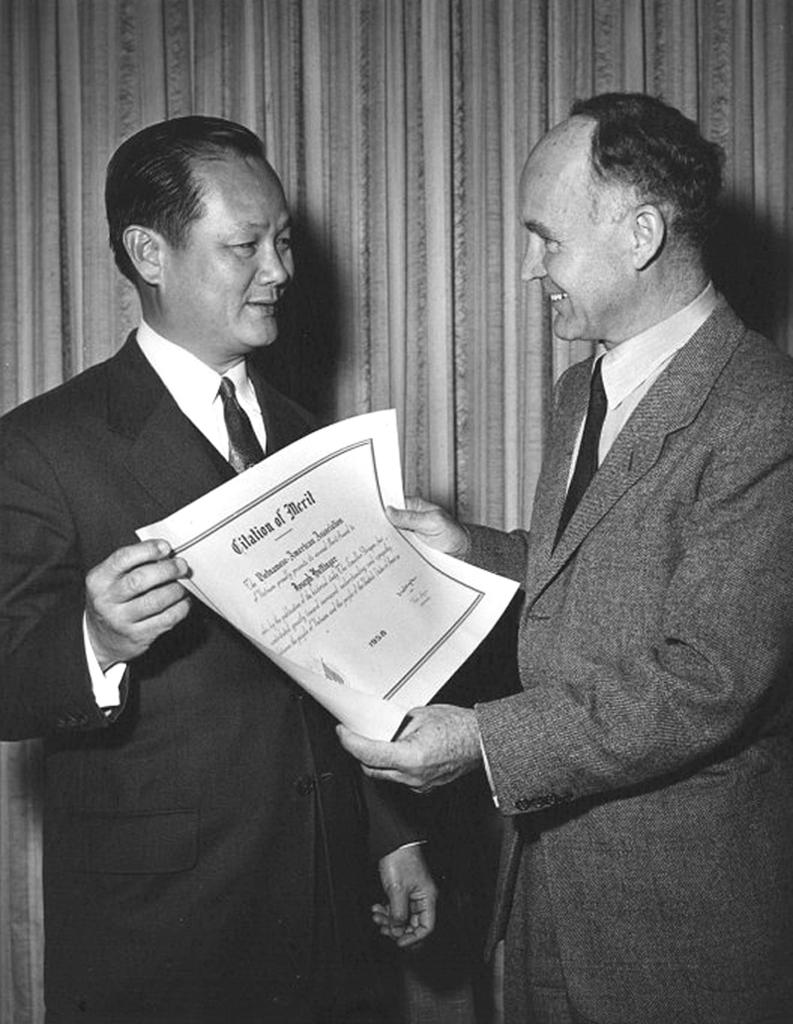How many people are in the image? There are two persons in the image. Where are the two persons located in the image? The two persons are standing in the middle of the image. What are the two persons holding in the image? The two persons are holding a white color paper. What can be seen in the background of the image? There is a curtain in the background of the image. What type of brick is visible on the floor in the image? There is no brick visible on the floor in the image. How many steps are taken by the persons in the image? The persons are standing still in the image, so no steps are taken. 